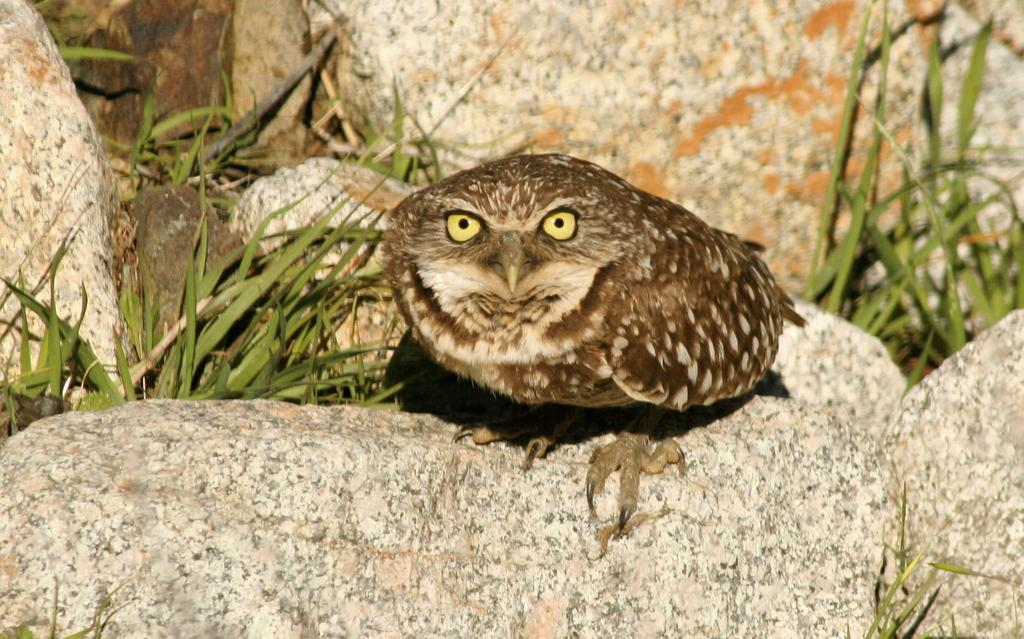What animal is in the picture? There is an owl in the picture. What is the owl standing on? The owl is standing on a stone. Are there any other stones visible in the picture? Yes, there are stones in the picture. What type of vegetation can be seen in the picture? There are plants in the picture. What type of humor can be seen in the picture? There is no humor present in the image; it features an owl standing on a stone with other stones and plants in the background. 